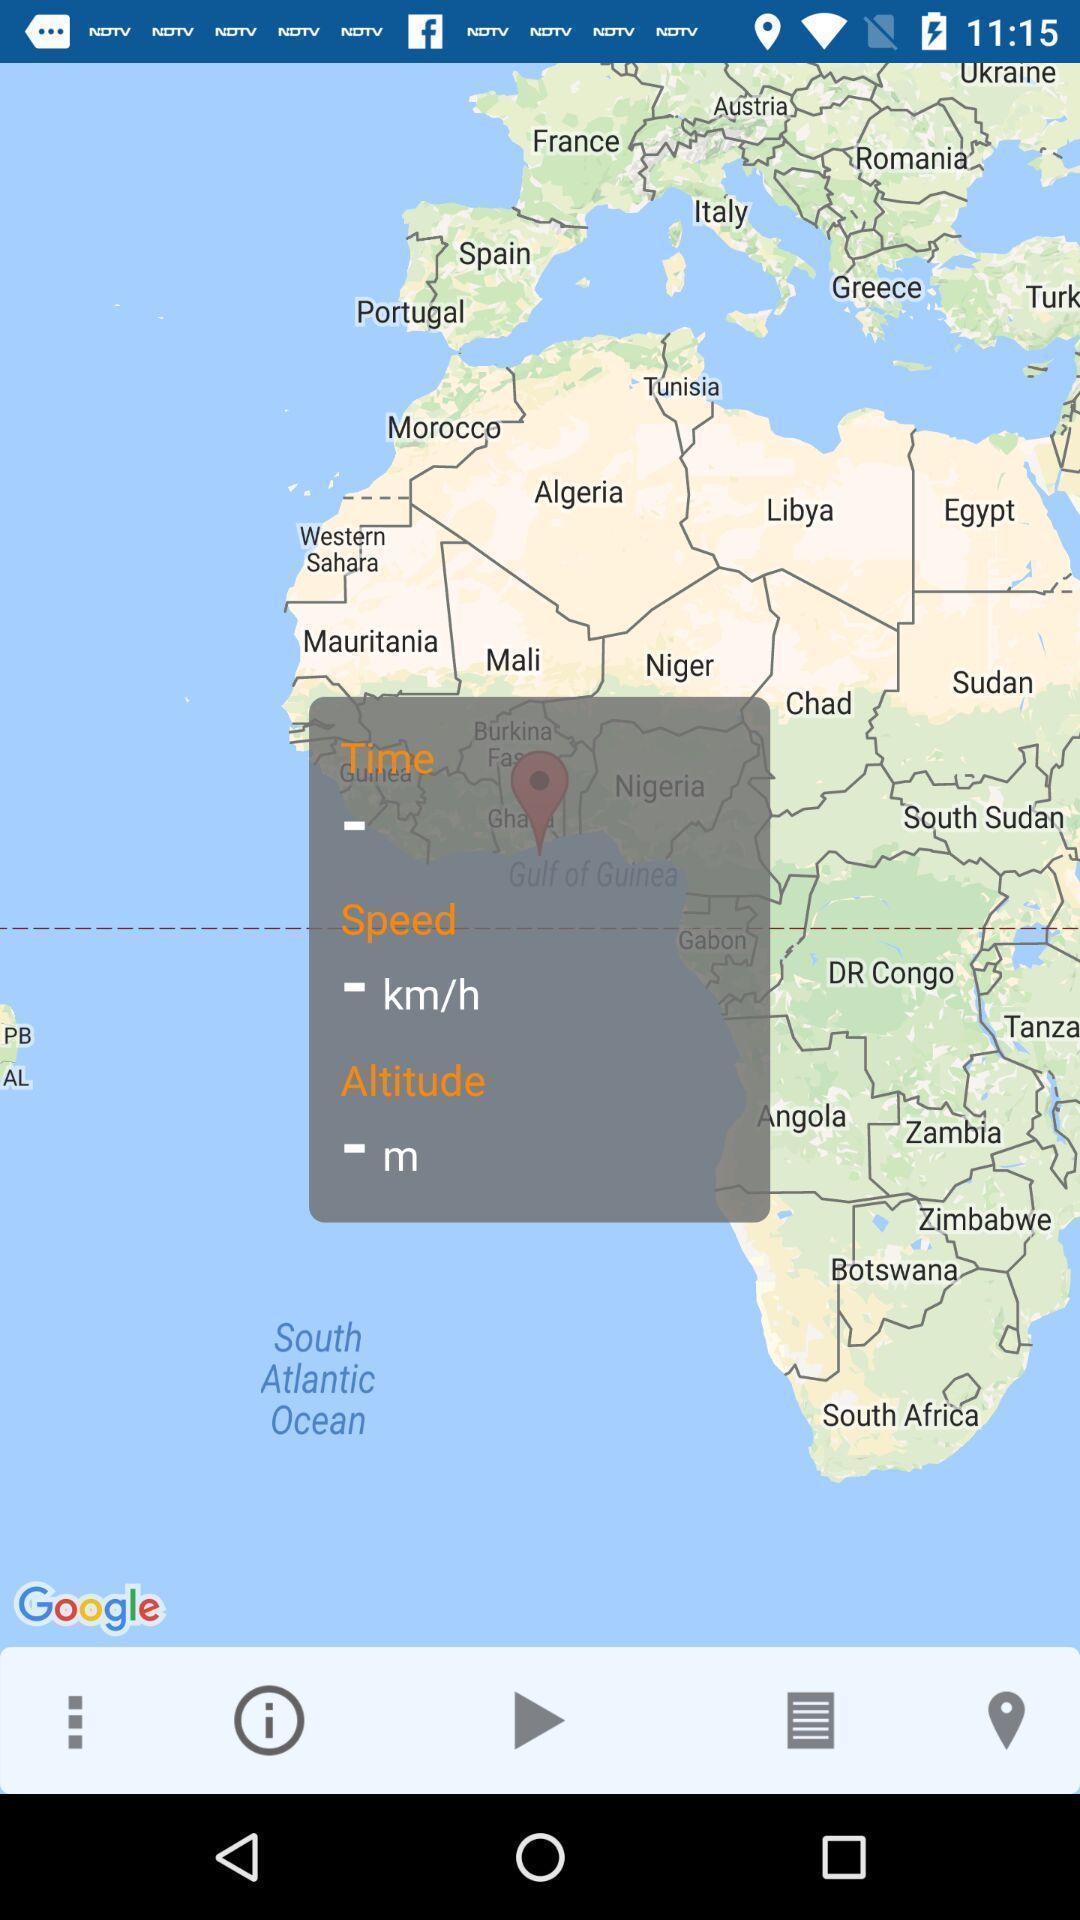Give me a narrative description of this picture. Pop-up of parameters on a map of navigation app. 